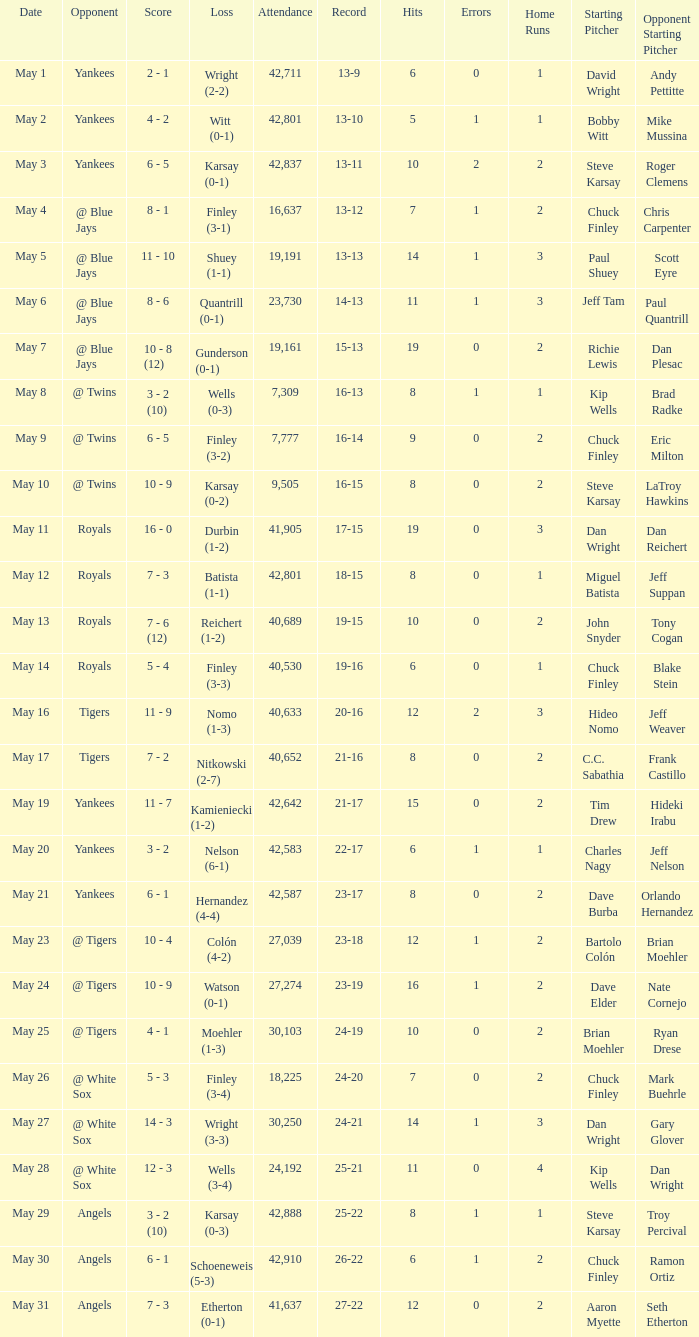What is the attendance for the game on May 25? 30103.0. 